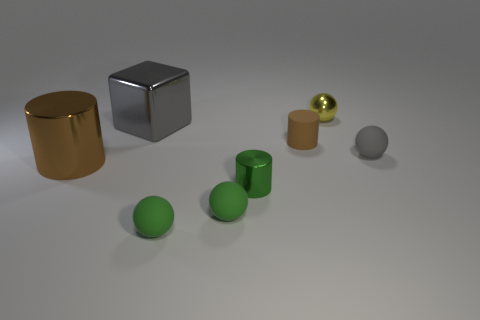Subtract 1 balls. How many balls are left? 3 Add 1 tiny yellow shiny spheres. How many objects exist? 9 Subtract all blocks. How many objects are left? 7 Subtract all green metal cylinders. Subtract all large brown metal things. How many objects are left? 6 Add 1 large brown metal cylinders. How many large brown metal cylinders are left? 2 Add 3 gray objects. How many gray objects exist? 5 Subtract 0 blue cylinders. How many objects are left? 8 